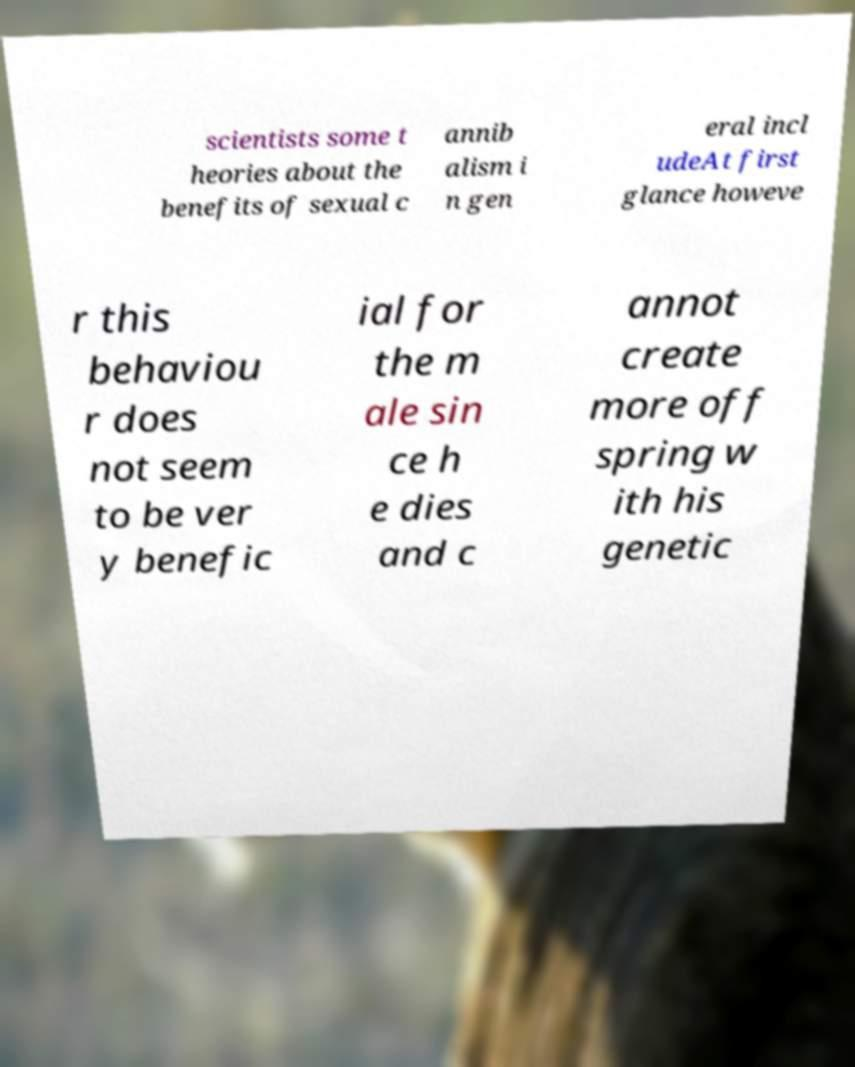I need the written content from this picture converted into text. Can you do that? scientists some t heories about the benefits of sexual c annib alism i n gen eral incl udeAt first glance howeve r this behaviou r does not seem to be ver y benefic ial for the m ale sin ce h e dies and c annot create more off spring w ith his genetic 